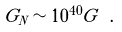Convert formula to latex. <formula><loc_0><loc_0><loc_500><loc_500>G _ { N } \sim 1 0 ^ { 4 0 } G \ .</formula> 